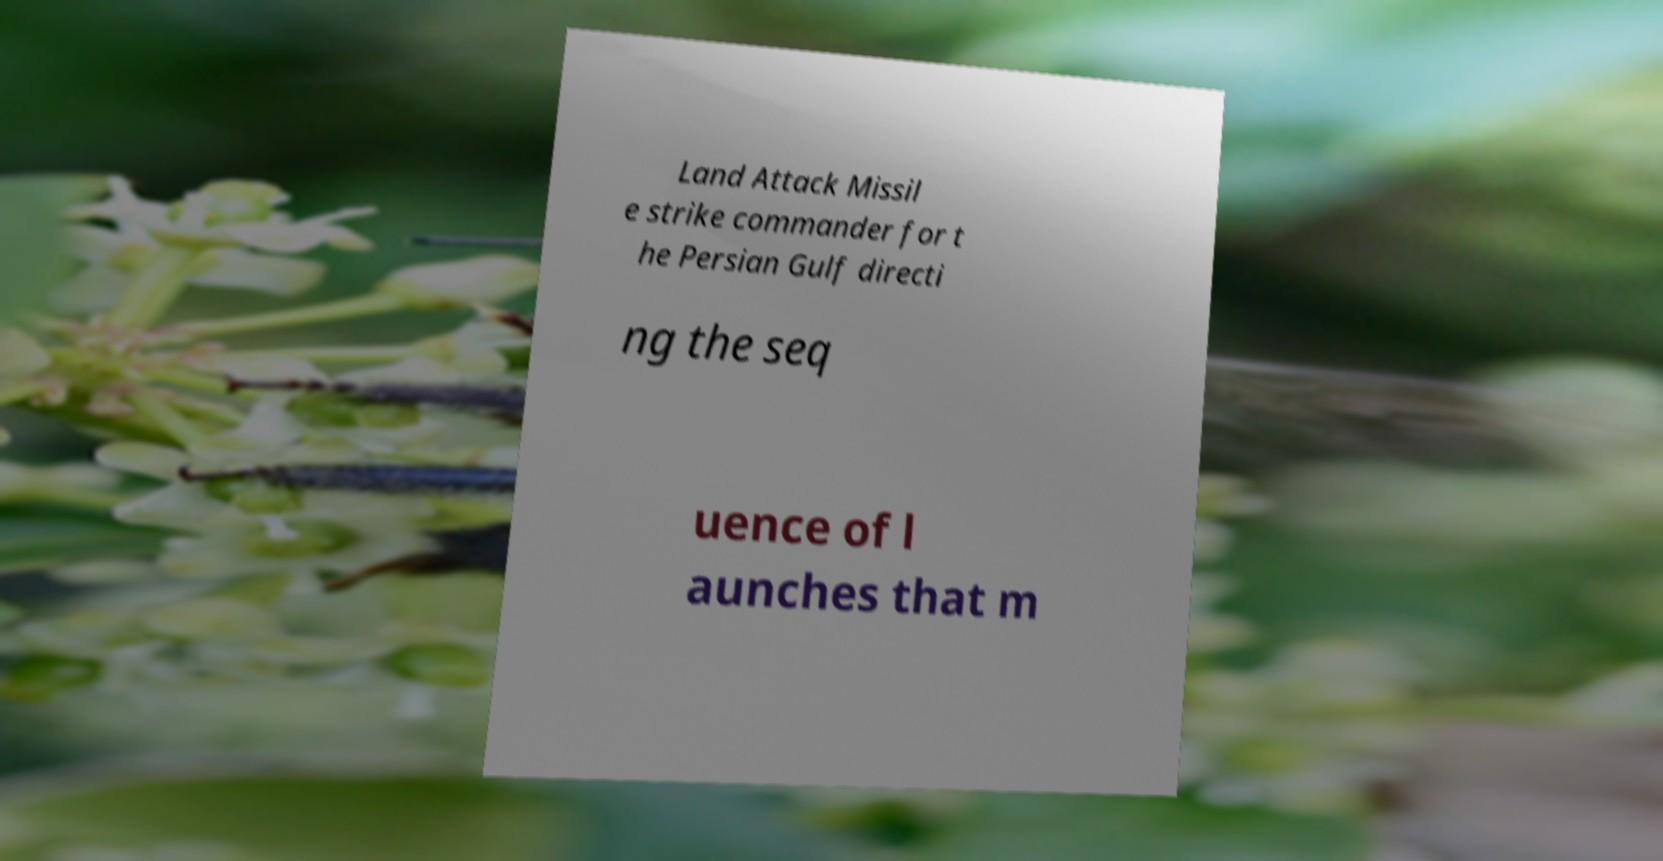What messages or text are displayed in this image? I need them in a readable, typed format. Land Attack Missil e strike commander for t he Persian Gulf directi ng the seq uence of l aunches that m 